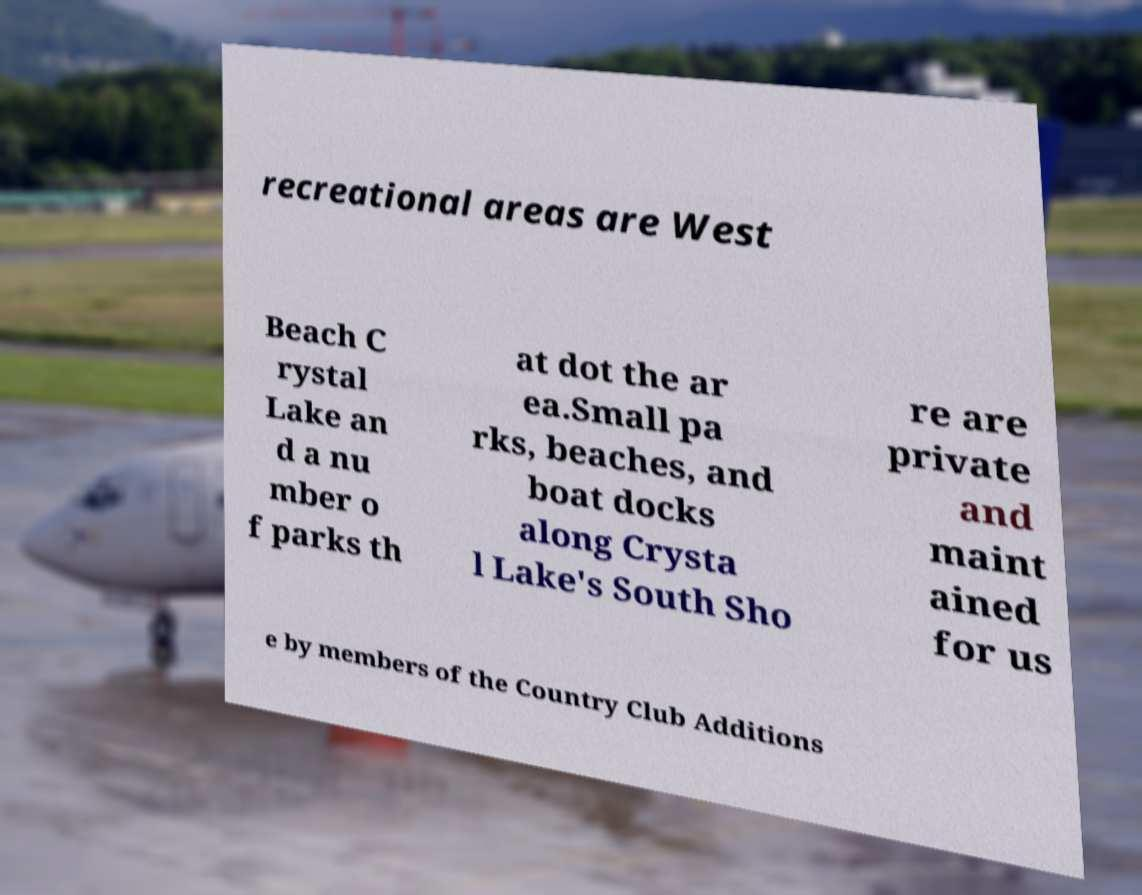Please read and relay the text visible in this image. What does it say? recreational areas are West Beach C rystal Lake an d a nu mber o f parks th at dot the ar ea.Small pa rks, beaches, and boat docks along Crysta l Lake's South Sho re are private and maint ained for us e by members of the Country Club Additions 